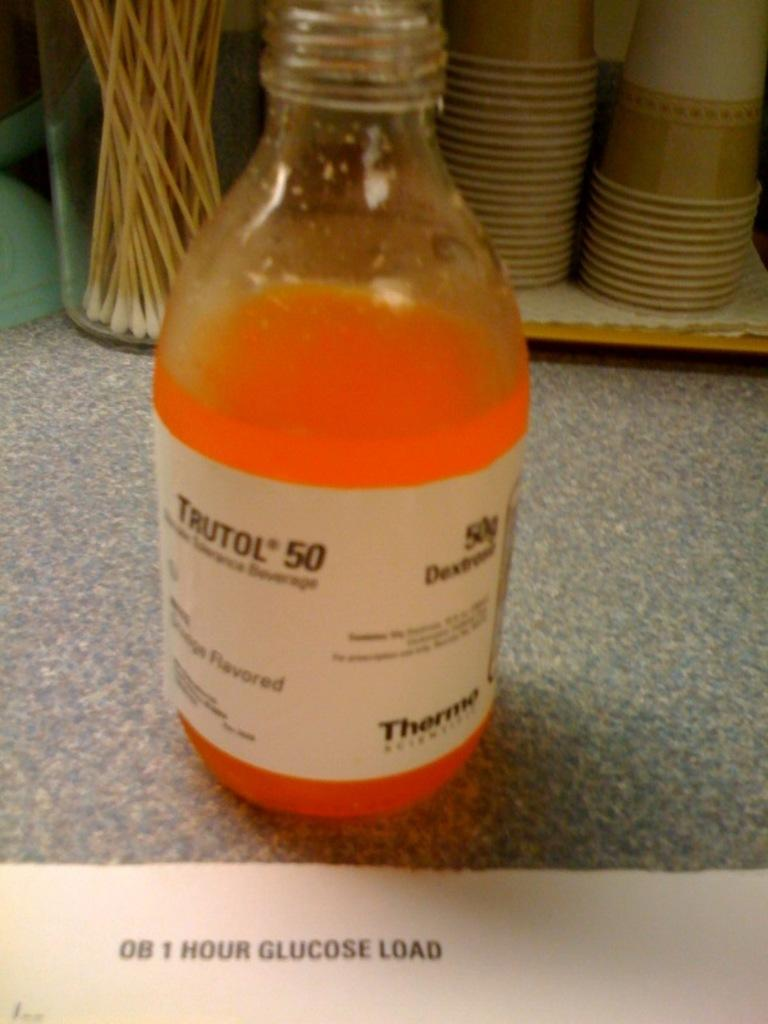<image>
Describe the image concisely. A bottle of Trutol 50 is seen close up and is a 1 Hour Glucose Load. 